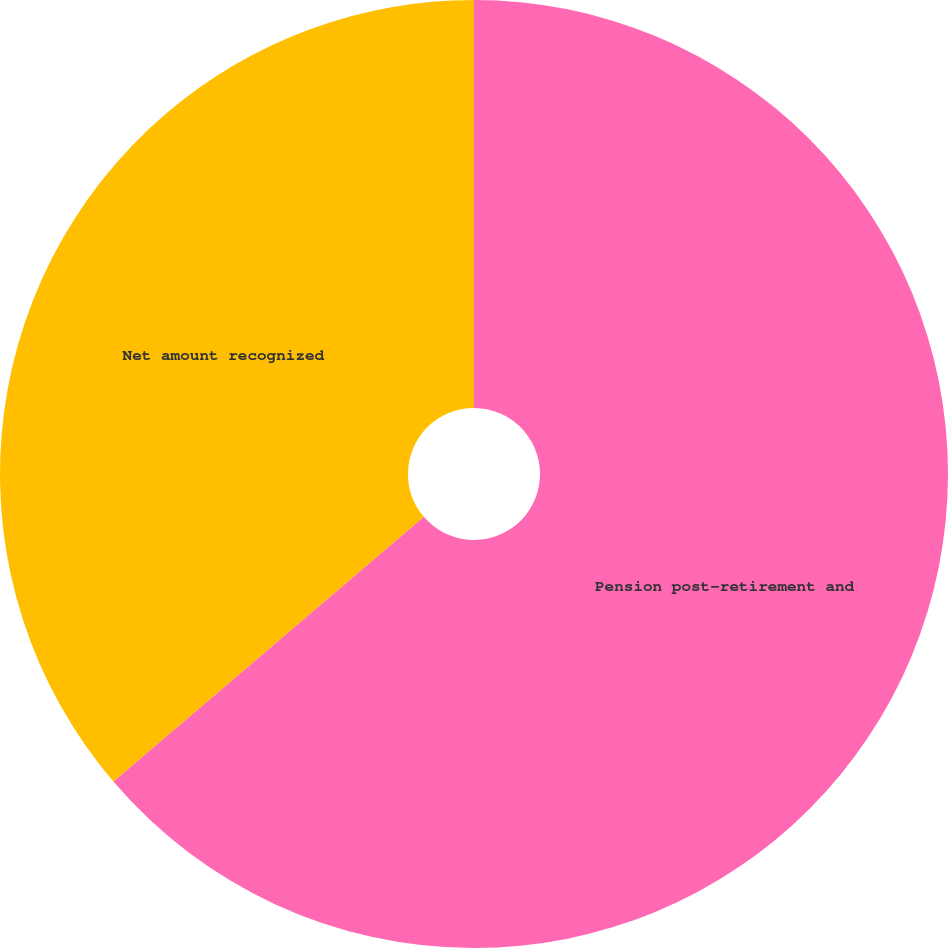<chart> <loc_0><loc_0><loc_500><loc_500><pie_chart><fcel>Pension post-retirement and<fcel>Net amount recognized<nl><fcel>63.76%<fcel>36.24%<nl></chart> 